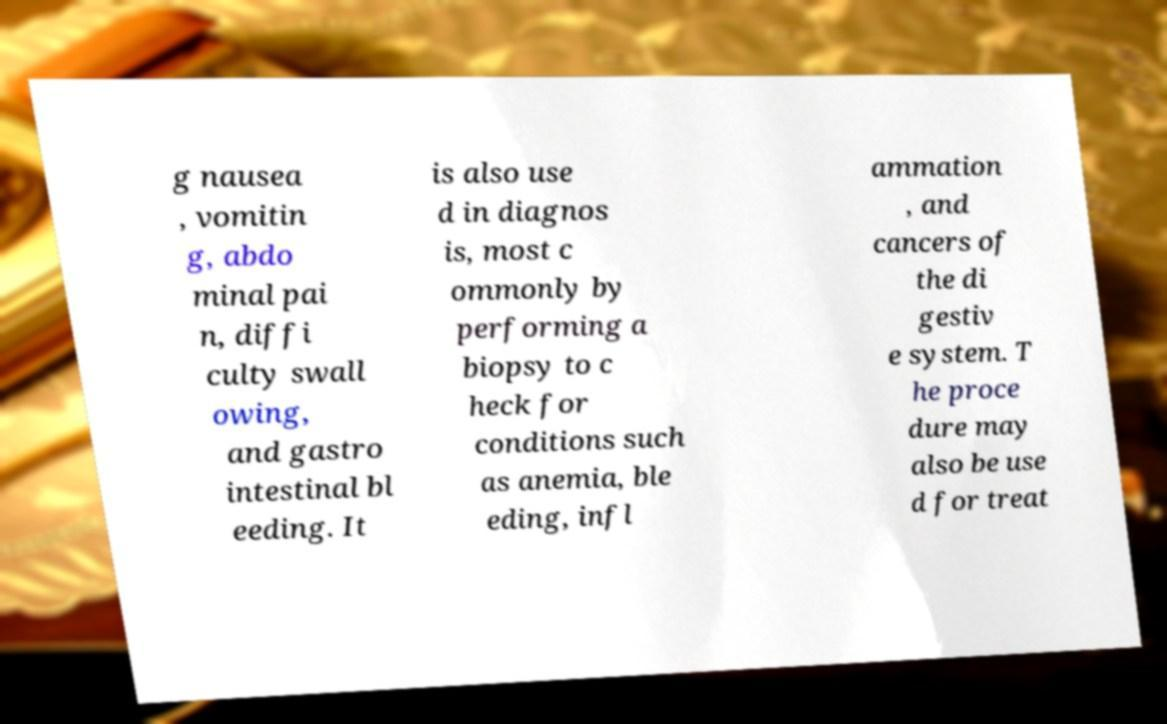Please identify and transcribe the text found in this image. g nausea , vomitin g, abdo minal pai n, diffi culty swall owing, and gastro intestinal bl eeding. It is also use d in diagnos is, most c ommonly by performing a biopsy to c heck for conditions such as anemia, ble eding, infl ammation , and cancers of the di gestiv e system. T he proce dure may also be use d for treat 